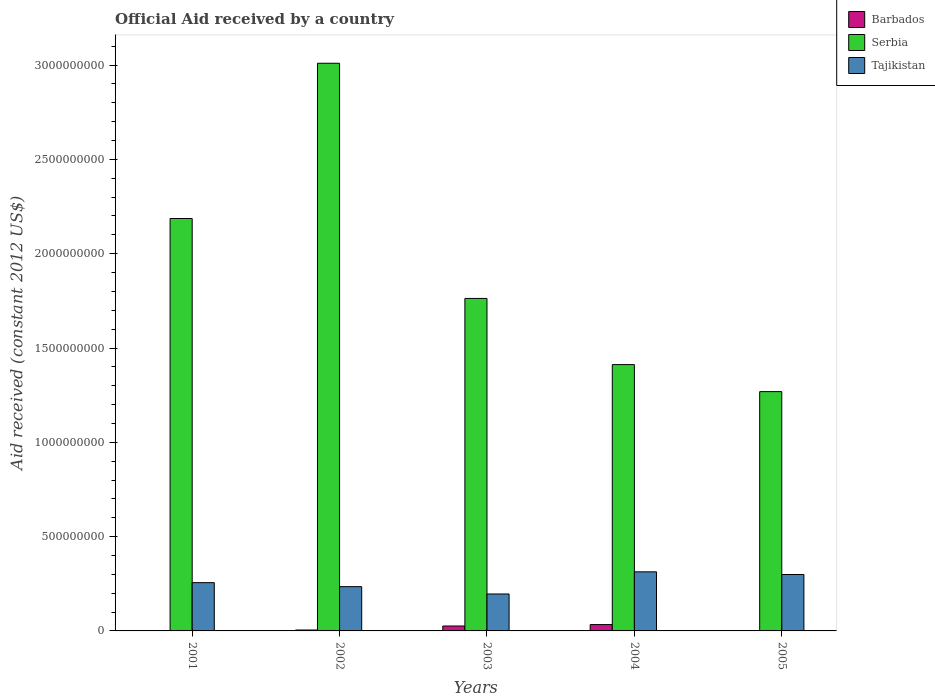How many different coloured bars are there?
Offer a very short reply. 3. Are the number of bars per tick equal to the number of legend labels?
Your answer should be compact. No. How many bars are there on the 5th tick from the left?
Offer a terse response. 2. How many bars are there on the 4th tick from the right?
Give a very brief answer. 3. In how many cases, is the number of bars for a given year not equal to the number of legend labels?
Offer a terse response. 2. What is the net official aid received in Serbia in 2003?
Your answer should be compact. 1.76e+09. Across all years, what is the maximum net official aid received in Barbados?
Your answer should be very brief. 3.37e+07. Across all years, what is the minimum net official aid received in Tajikistan?
Offer a very short reply. 1.96e+08. In which year was the net official aid received in Tajikistan maximum?
Keep it short and to the point. 2004. What is the total net official aid received in Serbia in the graph?
Offer a terse response. 9.64e+09. What is the difference between the net official aid received in Serbia in 2001 and that in 2004?
Make the answer very short. 7.75e+08. What is the difference between the net official aid received in Barbados in 2002 and the net official aid received in Tajikistan in 2004?
Your answer should be compact. -3.08e+08. What is the average net official aid received in Barbados per year?
Keep it short and to the point. 1.29e+07. In the year 2002, what is the difference between the net official aid received in Serbia and net official aid received in Barbados?
Make the answer very short. 3.00e+09. In how many years, is the net official aid received in Tajikistan greater than 3000000000 US$?
Offer a very short reply. 0. What is the ratio of the net official aid received in Tajikistan in 2004 to that in 2005?
Your answer should be very brief. 1.05. Is the net official aid received in Serbia in 2002 less than that in 2005?
Keep it short and to the point. No. Is the difference between the net official aid received in Serbia in 2003 and 2004 greater than the difference between the net official aid received in Barbados in 2003 and 2004?
Your answer should be compact. Yes. What is the difference between the highest and the second highest net official aid received in Serbia?
Your answer should be very brief. 8.23e+08. What is the difference between the highest and the lowest net official aid received in Tajikistan?
Your answer should be very brief. 1.17e+08. What is the difference between two consecutive major ticks on the Y-axis?
Give a very brief answer. 5.00e+08. Are the values on the major ticks of Y-axis written in scientific E-notation?
Your answer should be very brief. No. How many legend labels are there?
Make the answer very short. 3. How are the legend labels stacked?
Your answer should be compact. Vertical. What is the title of the graph?
Ensure brevity in your answer.  Official Aid received by a country. Does "Portugal" appear as one of the legend labels in the graph?
Offer a very short reply. No. What is the label or title of the X-axis?
Your answer should be compact. Years. What is the label or title of the Y-axis?
Keep it short and to the point. Aid received (constant 2012 US$). What is the Aid received (constant 2012 US$) of Serbia in 2001?
Make the answer very short. 2.19e+09. What is the Aid received (constant 2012 US$) of Tajikistan in 2001?
Offer a very short reply. 2.56e+08. What is the Aid received (constant 2012 US$) in Barbados in 2002?
Offer a very short reply. 4.88e+06. What is the Aid received (constant 2012 US$) of Serbia in 2002?
Your answer should be very brief. 3.01e+09. What is the Aid received (constant 2012 US$) in Tajikistan in 2002?
Make the answer very short. 2.35e+08. What is the Aid received (constant 2012 US$) in Barbados in 2003?
Give a very brief answer. 2.60e+07. What is the Aid received (constant 2012 US$) in Serbia in 2003?
Your answer should be very brief. 1.76e+09. What is the Aid received (constant 2012 US$) of Tajikistan in 2003?
Provide a short and direct response. 1.96e+08. What is the Aid received (constant 2012 US$) of Barbados in 2004?
Your answer should be very brief. 3.37e+07. What is the Aid received (constant 2012 US$) in Serbia in 2004?
Your response must be concise. 1.41e+09. What is the Aid received (constant 2012 US$) of Tajikistan in 2004?
Keep it short and to the point. 3.13e+08. What is the Aid received (constant 2012 US$) of Barbados in 2005?
Ensure brevity in your answer.  0. What is the Aid received (constant 2012 US$) of Serbia in 2005?
Your answer should be compact. 1.27e+09. What is the Aid received (constant 2012 US$) of Tajikistan in 2005?
Your answer should be very brief. 2.99e+08. Across all years, what is the maximum Aid received (constant 2012 US$) in Barbados?
Provide a succinct answer. 3.37e+07. Across all years, what is the maximum Aid received (constant 2012 US$) of Serbia?
Give a very brief answer. 3.01e+09. Across all years, what is the maximum Aid received (constant 2012 US$) in Tajikistan?
Your response must be concise. 3.13e+08. Across all years, what is the minimum Aid received (constant 2012 US$) of Serbia?
Ensure brevity in your answer.  1.27e+09. Across all years, what is the minimum Aid received (constant 2012 US$) of Tajikistan?
Your response must be concise. 1.96e+08. What is the total Aid received (constant 2012 US$) in Barbados in the graph?
Provide a short and direct response. 6.46e+07. What is the total Aid received (constant 2012 US$) in Serbia in the graph?
Offer a terse response. 9.64e+09. What is the total Aid received (constant 2012 US$) in Tajikistan in the graph?
Ensure brevity in your answer.  1.30e+09. What is the difference between the Aid received (constant 2012 US$) of Serbia in 2001 and that in 2002?
Keep it short and to the point. -8.23e+08. What is the difference between the Aid received (constant 2012 US$) of Tajikistan in 2001 and that in 2002?
Offer a terse response. 2.11e+07. What is the difference between the Aid received (constant 2012 US$) in Serbia in 2001 and that in 2003?
Give a very brief answer. 4.24e+08. What is the difference between the Aid received (constant 2012 US$) in Tajikistan in 2001 and that in 2003?
Provide a short and direct response. 6.00e+07. What is the difference between the Aid received (constant 2012 US$) of Serbia in 2001 and that in 2004?
Your answer should be very brief. 7.75e+08. What is the difference between the Aid received (constant 2012 US$) in Tajikistan in 2001 and that in 2004?
Ensure brevity in your answer.  -5.73e+07. What is the difference between the Aid received (constant 2012 US$) in Serbia in 2001 and that in 2005?
Offer a terse response. 9.18e+08. What is the difference between the Aid received (constant 2012 US$) of Tajikistan in 2001 and that in 2005?
Your response must be concise. -4.32e+07. What is the difference between the Aid received (constant 2012 US$) of Barbados in 2002 and that in 2003?
Provide a short and direct response. -2.11e+07. What is the difference between the Aid received (constant 2012 US$) of Serbia in 2002 and that in 2003?
Your answer should be compact. 1.25e+09. What is the difference between the Aid received (constant 2012 US$) in Tajikistan in 2002 and that in 2003?
Give a very brief answer. 3.89e+07. What is the difference between the Aid received (constant 2012 US$) in Barbados in 2002 and that in 2004?
Offer a terse response. -2.88e+07. What is the difference between the Aid received (constant 2012 US$) of Serbia in 2002 and that in 2004?
Make the answer very short. 1.60e+09. What is the difference between the Aid received (constant 2012 US$) in Tajikistan in 2002 and that in 2004?
Your answer should be compact. -7.85e+07. What is the difference between the Aid received (constant 2012 US$) in Serbia in 2002 and that in 2005?
Your response must be concise. 1.74e+09. What is the difference between the Aid received (constant 2012 US$) in Tajikistan in 2002 and that in 2005?
Your answer should be very brief. -6.43e+07. What is the difference between the Aid received (constant 2012 US$) of Barbados in 2003 and that in 2004?
Provide a succinct answer. -7.69e+06. What is the difference between the Aid received (constant 2012 US$) of Serbia in 2003 and that in 2004?
Ensure brevity in your answer.  3.51e+08. What is the difference between the Aid received (constant 2012 US$) in Tajikistan in 2003 and that in 2004?
Offer a terse response. -1.17e+08. What is the difference between the Aid received (constant 2012 US$) of Serbia in 2003 and that in 2005?
Provide a short and direct response. 4.94e+08. What is the difference between the Aid received (constant 2012 US$) in Tajikistan in 2003 and that in 2005?
Provide a succinct answer. -1.03e+08. What is the difference between the Aid received (constant 2012 US$) of Serbia in 2004 and that in 2005?
Provide a succinct answer. 1.43e+08. What is the difference between the Aid received (constant 2012 US$) of Tajikistan in 2004 and that in 2005?
Make the answer very short. 1.41e+07. What is the difference between the Aid received (constant 2012 US$) of Serbia in 2001 and the Aid received (constant 2012 US$) of Tajikistan in 2002?
Keep it short and to the point. 1.95e+09. What is the difference between the Aid received (constant 2012 US$) in Serbia in 2001 and the Aid received (constant 2012 US$) in Tajikistan in 2003?
Keep it short and to the point. 1.99e+09. What is the difference between the Aid received (constant 2012 US$) of Serbia in 2001 and the Aid received (constant 2012 US$) of Tajikistan in 2004?
Provide a short and direct response. 1.87e+09. What is the difference between the Aid received (constant 2012 US$) in Serbia in 2001 and the Aid received (constant 2012 US$) in Tajikistan in 2005?
Provide a succinct answer. 1.89e+09. What is the difference between the Aid received (constant 2012 US$) in Barbados in 2002 and the Aid received (constant 2012 US$) in Serbia in 2003?
Ensure brevity in your answer.  -1.76e+09. What is the difference between the Aid received (constant 2012 US$) of Barbados in 2002 and the Aid received (constant 2012 US$) of Tajikistan in 2003?
Make the answer very short. -1.91e+08. What is the difference between the Aid received (constant 2012 US$) of Serbia in 2002 and the Aid received (constant 2012 US$) of Tajikistan in 2003?
Provide a short and direct response. 2.81e+09. What is the difference between the Aid received (constant 2012 US$) in Barbados in 2002 and the Aid received (constant 2012 US$) in Serbia in 2004?
Make the answer very short. -1.41e+09. What is the difference between the Aid received (constant 2012 US$) of Barbados in 2002 and the Aid received (constant 2012 US$) of Tajikistan in 2004?
Offer a very short reply. -3.08e+08. What is the difference between the Aid received (constant 2012 US$) in Serbia in 2002 and the Aid received (constant 2012 US$) in Tajikistan in 2004?
Keep it short and to the point. 2.70e+09. What is the difference between the Aid received (constant 2012 US$) in Barbados in 2002 and the Aid received (constant 2012 US$) in Serbia in 2005?
Your answer should be compact. -1.26e+09. What is the difference between the Aid received (constant 2012 US$) of Barbados in 2002 and the Aid received (constant 2012 US$) of Tajikistan in 2005?
Your response must be concise. -2.94e+08. What is the difference between the Aid received (constant 2012 US$) of Serbia in 2002 and the Aid received (constant 2012 US$) of Tajikistan in 2005?
Make the answer very short. 2.71e+09. What is the difference between the Aid received (constant 2012 US$) in Barbados in 2003 and the Aid received (constant 2012 US$) in Serbia in 2004?
Offer a terse response. -1.39e+09. What is the difference between the Aid received (constant 2012 US$) in Barbados in 2003 and the Aid received (constant 2012 US$) in Tajikistan in 2004?
Give a very brief answer. -2.87e+08. What is the difference between the Aid received (constant 2012 US$) in Serbia in 2003 and the Aid received (constant 2012 US$) in Tajikistan in 2004?
Provide a succinct answer. 1.45e+09. What is the difference between the Aid received (constant 2012 US$) in Barbados in 2003 and the Aid received (constant 2012 US$) in Serbia in 2005?
Offer a terse response. -1.24e+09. What is the difference between the Aid received (constant 2012 US$) of Barbados in 2003 and the Aid received (constant 2012 US$) of Tajikistan in 2005?
Provide a short and direct response. -2.73e+08. What is the difference between the Aid received (constant 2012 US$) in Serbia in 2003 and the Aid received (constant 2012 US$) in Tajikistan in 2005?
Ensure brevity in your answer.  1.46e+09. What is the difference between the Aid received (constant 2012 US$) in Barbados in 2004 and the Aid received (constant 2012 US$) in Serbia in 2005?
Offer a terse response. -1.24e+09. What is the difference between the Aid received (constant 2012 US$) of Barbados in 2004 and the Aid received (constant 2012 US$) of Tajikistan in 2005?
Ensure brevity in your answer.  -2.65e+08. What is the difference between the Aid received (constant 2012 US$) of Serbia in 2004 and the Aid received (constant 2012 US$) of Tajikistan in 2005?
Your answer should be compact. 1.11e+09. What is the average Aid received (constant 2012 US$) in Barbados per year?
Provide a succinct answer. 1.29e+07. What is the average Aid received (constant 2012 US$) of Serbia per year?
Make the answer very short. 1.93e+09. What is the average Aid received (constant 2012 US$) in Tajikistan per year?
Your answer should be compact. 2.60e+08. In the year 2001, what is the difference between the Aid received (constant 2012 US$) in Serbia and Aid received (constant 2012 US$) in Tajikistan?
Provide a succinct answer. 1.93e+09. In the year 2002, what is the difference between the Aid received (constant 2012 US$) of Barbados and Aid received (constant 2012 US$) of Serbia?
Offer a terse response. -3.00e+09. In the year 2002, what is the difference between the Aid received (constant 2012 US$) in Barbados and Aid received (constant 2012 US$) in Tajikistan?
Your answer should be very brief. -2.30e+08. In the year 2002, what is the difference between the Aid received (constant 2012 US$) in Serbia and Aid received (constant 2012 US$) in Tajikistan?
Your answer should be very brief. 2.77e+09. In the year 2003, what is the difference between the Aid received (constant 2012 US$) in Barbados and Aid received (constant 2012 US$) in Serbia?
Give a very brief answer. -1.74e+09. In the year 2003, what is the difference between the Aid received (constant 2012 US$) in Barbados and Aid received (constant 2012 US$) in Tajikistan?
Give a very brief answer. -1.70e+08. In the year 2003, what is the difference between the Aid received (constant 2012 US$) in Serbia and Aid received (constant 2012 US$) in Tajikistan?
Keep it short and to the point. 1.57e+09. In the year 2004, what is the difference between the Aid received (constant 2012 US$) of Barbados and Aid received (constant 2012 US$) of Serbia?
Give a very brief answer. -1.38e+09. In the year 2004, what is the difference between the Aid received (constant 2012 US$) in Barbados and Aid received (constant 2012 US$) in Tajikistan?
Provide a succinct answer. -2.80e+08. In the year 2004, what is the difference between the Aid received (constant 2012 US$) in Serbia and Aid received (constant 2012 US$) in Tajikistan?
Ensure brevity in your answer.  1.10e+09. In the year 2005, what is the difference between the Aid received (constant 2012 US$) in Serbia and Aid received (constant 2012 US$) in Tajikistan?
Provide a short and direct response. 9.70e+08. What is the ratio of the Aid received (constant 2012 US$) in Serbia in 2001 to that in 2002?
Your response must be concise. 0.73. What is the ratio of the Aid received (constant 2012 US$) in Tajikistan in 2001 to that in 2002?
Give a very brief answer. 1.09. What is the ratio of the Aid received (constant 2012 US$) in Serbia in 2001 to that in 2003?
Provide a succinct answer. 1.24. What is the ratio of the Aid received (constant 2012 US$) of Tajikistan in 2001 to that in 2003?
Ensure brevity in your answer.  1.31. What is the ratio of the Aid received (constant 2012 US$) in Serbia in 2001 to that in 2004?
Your answer should be very brief. 1.55. What is the ratio of the Aid received (constant 2012 US$) in Tajikistan in 2001 to that in 2004?
Provide a succinct answer. 0.82. What is the ratio of the Aid received (constant 2012 US$) of Serbia in 2001 to that in 2005?
Offer a very short reply. 1.72. What is the ratio of the Aid received (constant 2012 US$) of Tajikistan in 2001 to that in 2005?
Provide a succinct answer. 0.86. What is the ratio of the Aid received (constant 2012 US$) in Barbados in 2002 to that in 2003?
Provide a short and direct response. 0.19. What is the ratio of the Aid received (constant 2012 US$) of Serbia in 2002 to that in 2003?
Ensure brevity in your answer.  1.71. What is the ratio of the Aid received (constant 2012 US$) of Tajikistan in 2002 to that in 2003?
Your answer should be very brief. 1.2. What is the ratio of the Aid received (constant 2012 US$) in Barbados in 2002 to that in 2004?
Provide a succinct answer. 0.14. What is the ratio of the Aid received (constant 2012 US$) of Serbia in 2002 to that in 2004?
Give a very brief answer. 2.13. What is the ratio of the Aid received (constant 2012 US$) in Tajikistan in 2002 to that in 2004?
Provide a short and direct response. 0.75. What is the ratio of the Aid received (constant 2012 US$) in Serbia in 2002 to that in 2005?
Provide a succinct answer. 2.37. What is the ratio of the Aid received (constant 2012 US$) of Tajikistan in 2002 to that in 2005?
Your answer should be very brief. 0.78. What is the ratio of the Aid received (constant 2012 US$) of Barbados in 2003 to that in 2004?
Your response must be concise. 0.77. What is the ratio of the Aid received (constant 2012 US$) in Serbia in 2003 to that in 2004?
Your response must be concise. 1.25. What is the ratio of the Aid received (constant 2012 US$) of Tajikistan in 2003 to that in 2004?
Keep it short and to the point. 0.63. What is the ratio of the Aid received (constant 2012 US$) in Serbia in 2003 to that in 2005?
Your answer should be very brief. 1.39. What is the ratio of the Aid received (constant 2012 US$) of Tajikistan in 2003 to that in 2005?
Ensure brevity in your answer.  0.65. What is the ratio of the Aid received (constant 2012 US$) of Serbia in 2004 to that in 2005?
Your answer should be very brief. 1.11. What is the ratio of the Aid received (constant 2012 US$) in Tajikistan in 2004 to that in 2005?
Your response must be concise. 1.05. What is the difference between the highest and the second highest Aid received (constant 2012 US$) in Barbados?
Provide a short and direct response. 7.69e+06. What is the difference between the highest and the second highest Aid received (constant 2012 US$) of Serbia?
Ensure brevity in your answer.  8.23e+08. What is the difference between the highest and the second highest Aid received (constant 2012 US$) in Tajikistan?
Offer a very short reply. 1.41e+07. What is the difference between the highest and the lowest Aid received (constant 2012 US$) of Barbados?
Ensure brevity in your answer.  3.37e+07. What is the difference between the highest and the lowest Aid received (constant 2012 US$) of Serbia?
Your response must be concise. 1.74e+09. What is the difference between the highest and the lowest Aid received (constant 2012 US$) in Tajikistan?
Your answer should be compact. 1.17e+08. 